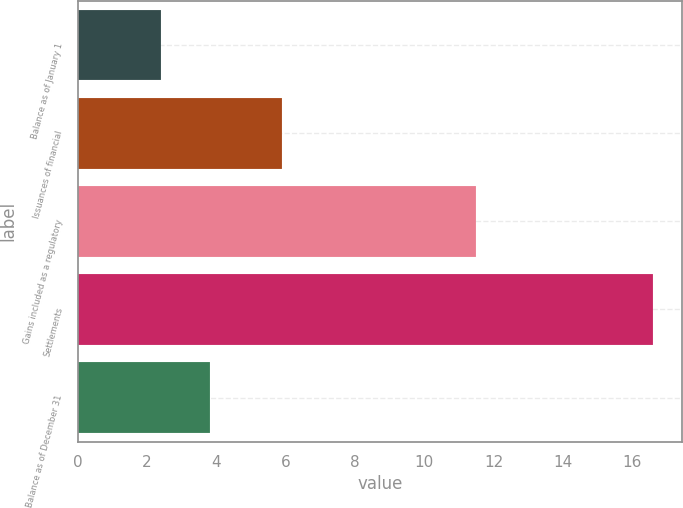Convert chart. <chart><loc_0><loc_0><loc_500><loc_500><bar_chart><fcel>Balance as of January 1<fcel>Issuances of financial<fcel>Gains included as a regulatory<fcel>Settlements<fcel>Balance as of December 31<nl><fcel>2.4<fcel>5.9<fcel>11.5<fcel>16.6<fcel>3.82<nl></chart> 